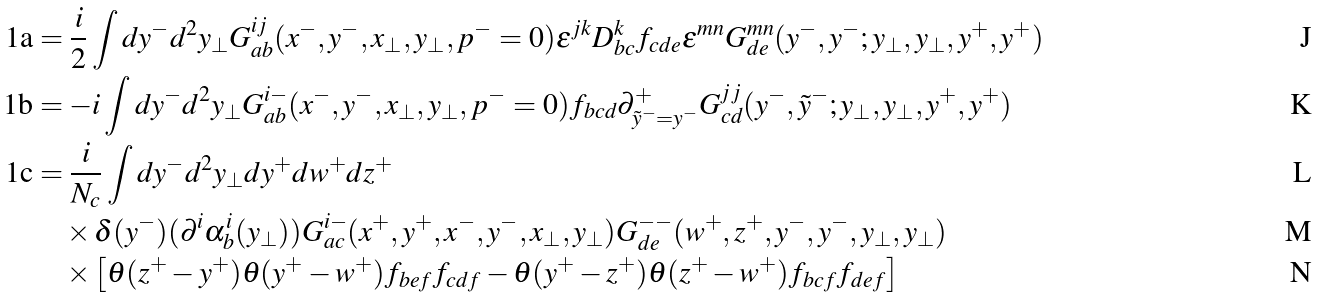<formula> <loc_0><loc_0><loc_500><loc_500>\text {1a} & = \frac { i } { 2 } \int d y ^ { - } d ^ { 2 } y _ { \perp } G ^ { i j } _ { a b } ( x ^ { - } , y ^ { - } , x _ { \perp } , y _ { \perp } , p ^ { - } = 0 ) \epsilon ^ { j k } D ^ { k } _ { b c } f _ { c d e } \epsilon ^ { m n } G ^ { m n } _ { d e } ( y ^ { - } , y ^ { - } ; y _ { \perp } , y _ { \perp } , y ^ { + } , y ^ { + } ) \\ \text {1b} & = - i \int d y ^ { - } d ^ { 2 } y _ { \perp } G ^ { i - } _ { a b } ( x ^ { - } , y ^ { - } , x _ { \perp } , y _ { \perp } , p ^ { - } = 0 ) f _ { b c d } { \partial } ^ { + } _ { \tilde { y } ^ { - } = y ^ { - } } G ^ { j j } _ { c d } ( y ^ { - } , \tilde { y } ^ { - } ; y _ { \perp } , y _ { \perp } , y ^ { + } , y ^ { + } ) \\ \text {1c} & = \frac { i } { N _ { c } } \int d y ^ { - } d ^ { 2 } y _ { \perp } d y ^ { + } d w ^ { + } d z ^ { + } \\ & \quad \times \delta ( y ^ { - } ) ( { \partial } ^ { i } { \alpha } ^ { i } _ { b } ( y _ { \perp } ) ) G ^ { i - } _ { a c } ( x ^ { + } , y ^ { + } , x ^ { - } , y ^ { - } , x _ { \perp } , y _ { \perp } ) G ^ { - - } _ { d e } ( w ^ { + } , z ^ { + } , y ^ { - } , y ^ { - } , y _ { \perp } , y _ { \perp } ) \\ & \quad \times \left [ \theta ( z ^ { + } - y ^ { + } ) \theta ( y ^ { + } - w ^ { + } ) f _ { b e f } f _ { c d f } - \theta ( y ^ { + } - z ^ { + } ) \theta ( z ^ { + } - w ^ { + } ) f _ { b c f } f _ { d e f } \right ]</formula> 